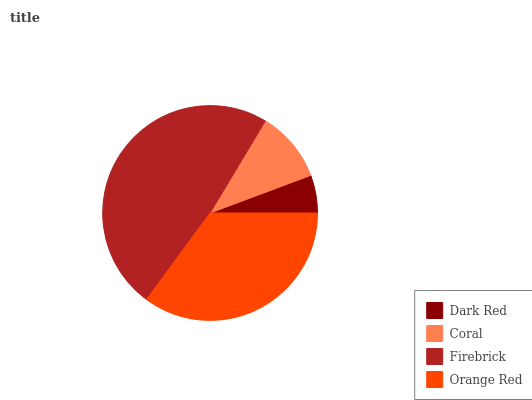Is Dark Red the minimum?
Answer yes or no. Yes. Is Firebrick the maximum?
Answer yes or no. Yes. Is Coral the minimum?
Answer yes or no. No. Is Coral the maximum?
Answer yes or no. No. Is Coral greater than Dark Red?
Answer yes or no. Yes. Is Dark Red less than Coral?
Answer yes or no. Yes. Is Dark Red greater than Coral?
Answer yes or no. No. Is Coral less than Dark Red?
Answer yes or no. No. Is Orange Red the high median?
Answer yes or no. Yes. Is Coral the low median?
Answer yes or no. Yes. Is Coral the high median?
Answer yes or no. No. Is Orange Red the low median?
Answer yes or no. No. 